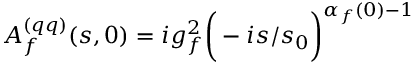<formula> <loc_0><loc_0><loc_500><loc_500>A _ { f } ^ { ( q q ) } ( s , 0 ) = i g _ { f } ^ { 2 } \left ( - i { s / s _ { 0 } } \right ) ^ { \alpha _ { f } ( 0 ) - 1 }</formula> 